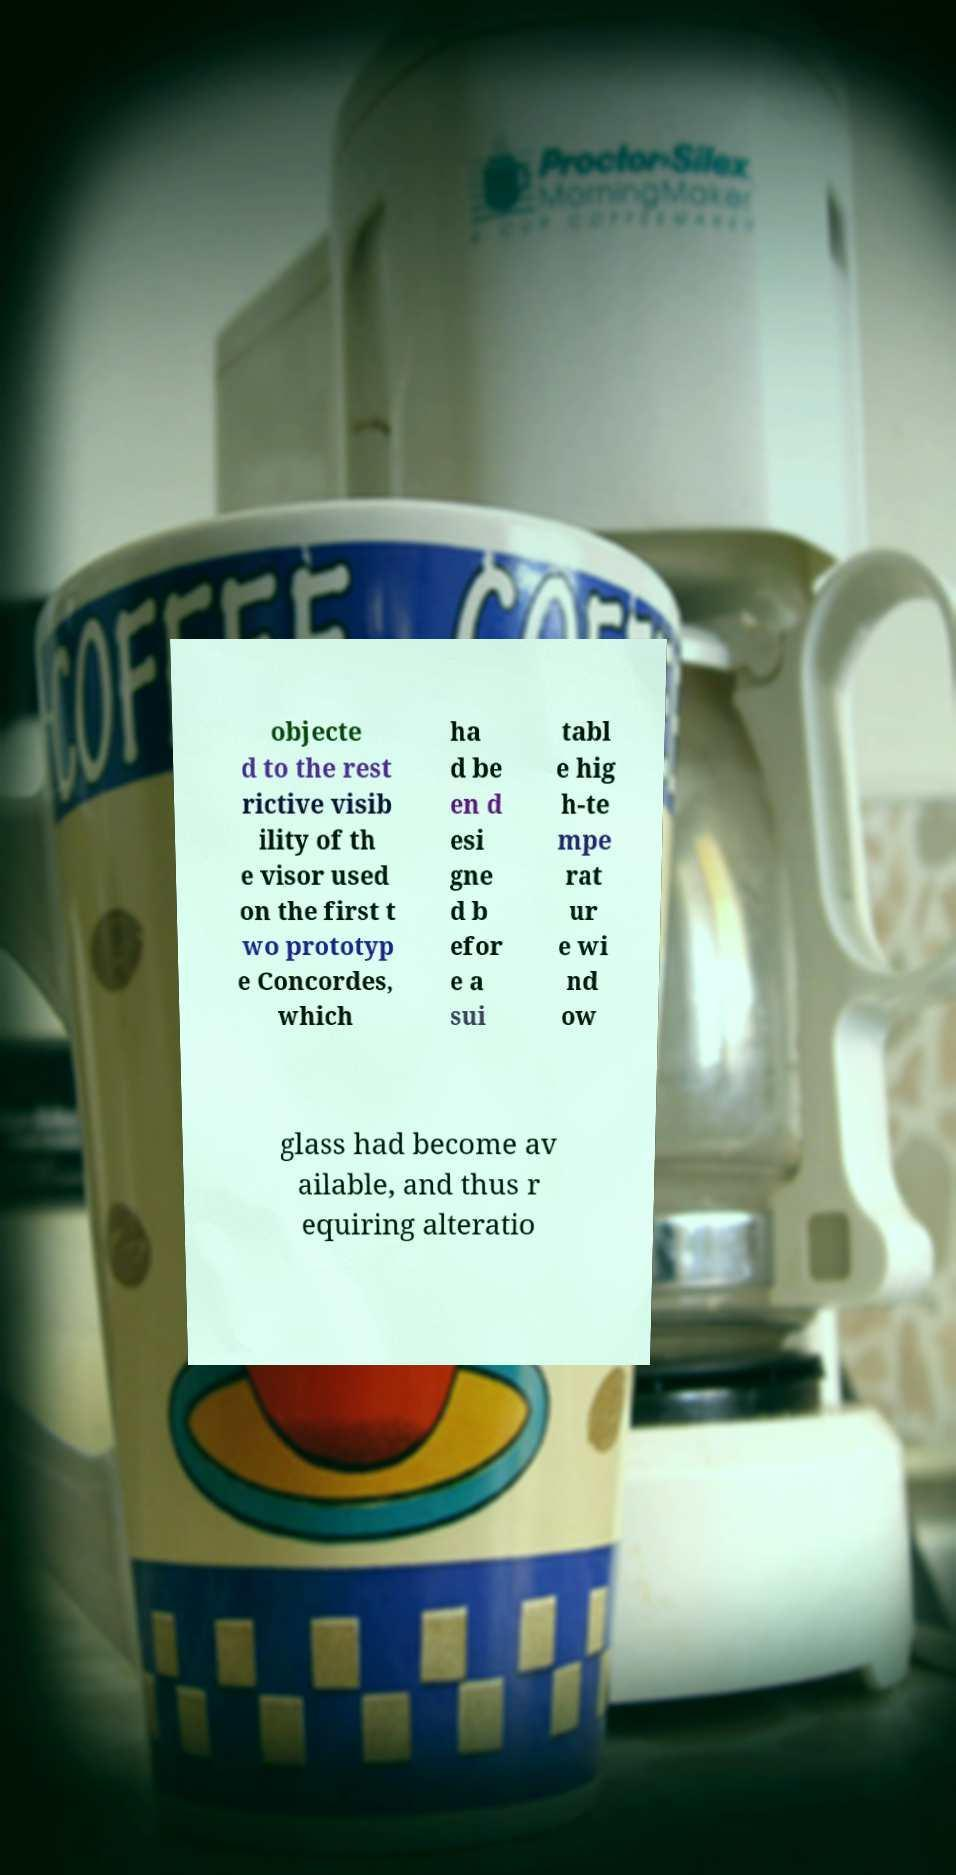I need the written content from this picture converted into text. Can you do that? objecte d to the rest rictive visib ility of th e visor used on the first t wo prototyp e Concordes, which ha d be en d esi gne d b efor e a sui tabl e hig h-te mpe rat ur e wi nd ow glass had become av ailable, and thus r equiring alteratio 